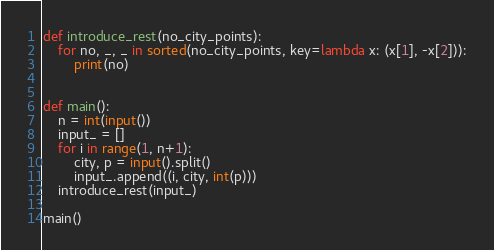<code> <loc_0><loc_0><loc_500><loc_500><_Python_>def introduce_rest(no_city_points):
    for no, _, _ in sorted(no_city_points, key=lambda x: (x[1], -x[2])):
        print(no)


def main():
    n = int(input())
    input_ = []
    for i in range(1, n+1):
        city, p = input().split()
        input_.append((i, city, int(p)))
    introduce_rest(input_)
    
main()</code> 